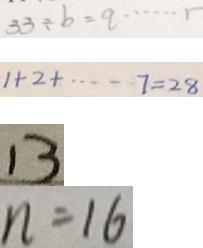Convert formula to latex. <formula><loc_0><loc_0><loc_500><loc_500>3 3 \div b = q \cdots r 
 1 + 2 + \cdots 7 = 2 8 
 1 3 
 n = 1 6</formula> 